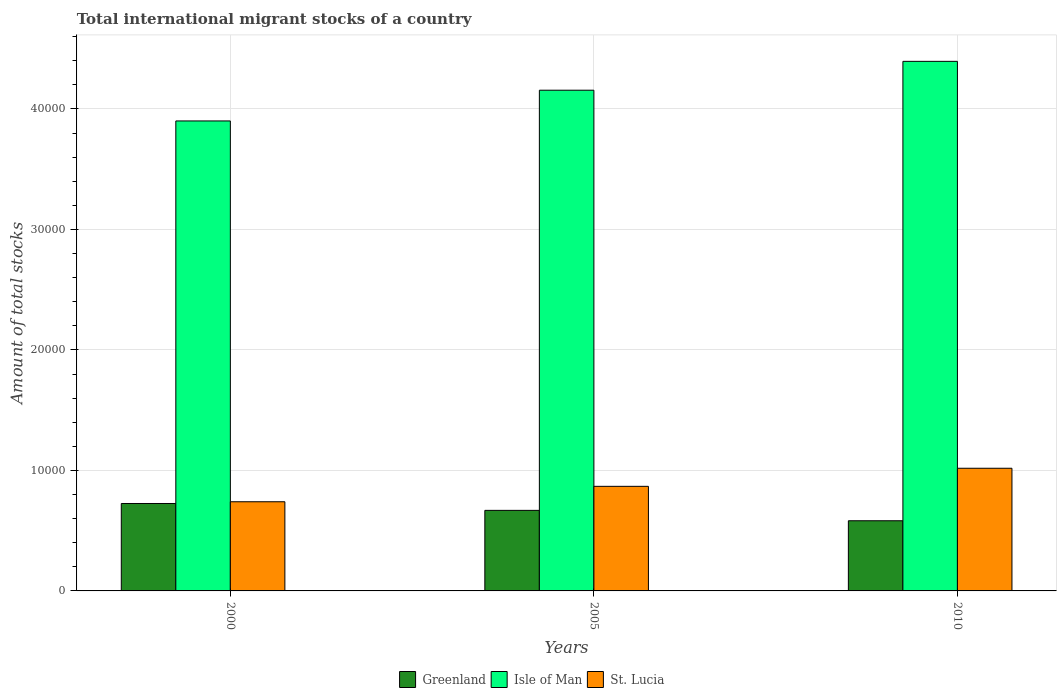Are the number of bars per tick equal to the number of legend labels?
Give a very brief answer. Yes. Are the number of bars on each tick of the X-axis equal?
Provide a succinct answer. Yes. What is the amount of total stocks in in Isle of Man in 2005?
Give a very brief answer. 4.16e+04. Across all years, what is the maximum amount of total stocks in in St. Lucia?
Give a very brief answer. 1.02e+04. Across all years, what is the minimum amount of total stocks in in Greenland?
Offer a very short reply. 5823. In which year was the amount of total stocks in in Isle of Man minimum?
Offer a terse response. 2000. What is the total amount of total stocks in in Isle of Man in the graph?
Offer a terse response. 1.25e+05. What is the difference between the amount of total stocks in in Isle of Man in 2000 and that in 2010?
Your response must be concise. -4945. What is the difference between the amount of total stocks in in St. Lucia in 2010 and the amount of total stocks in in Greenland in 2005?
Give a very brief answer. 3495. What is the average amount of total stocks in in St. Lucia per year?
Your response must be concise. 8753. In the year 2010, what is the difference between the amount of total stocks in in St. Lucia and amount of total stocks in in Isle of Man?
Ensure brevity in your answer.  -3.38e+04. In how many years, is the amount of total stocks in in St. Lucia greater than 2000?
Your response must be concise. 3. What is the ratio of the amount of total stocks in in St. Lucia in 2005 to that in 2010?
Give a very brief answer. 0.85. Is the amount of total stocks in in Greenland in 2000 less than that in 2005?
Make the answer very short. No. Is the difference between the amount of total stocks in in St. Lucia in 2000 and 2005 greater than the difference between the amount of total stocks in in Isle of Man in 2000 and 2005?
Provide a short and direct response. Yes. What is the difference between the highest and the second highest amount of total stocks in in St. Lucia?
Your answer should be very brief. 1501. What is the difference between the highest and the lowest amount of total stocks in in Greenland?
Make the answer very short. 1433. In how many years, is the amount of total stocks in in Greenland greater than the average amount of total stocks in in Greenland taken over all years?
Provide a succinct answer. 2. Is the sum of the amount of total stocks in in Isle of Man in 2000 and 2010 greater than the maximum amount of total stocks in in St. Lucia across all years?
Your answer should be compact. Yes. What does the 2nd bar from the left in 2010 represents?
Make the answer very short. Isle of Man. What does the 1st bar from the right in 2000 represents?
Keep it short and to the point. St. Lucia. Is it the case that in every year, the sum of the amount of total stocks in in Isle of Man and amount of total stocks in in Greenland is greater than the amount of total stocks in in St. Lucia?
Offer a very short reply. Yes. How many bars are there?
Keep it short and to the point. 9. Does the graph contain grids?
Give a very brief answer. Yes. How are the legend labels stacked?
Ensure brevity in your answer.  Horizontal. What is the title of the graph?
Your response must be concise. Total international migrant stocks of a country. What is the label or title of the Y-axis?
Give a very brief answer. Amount of total stocks. What is the Amount of total stocks in Greenland in 2000?
Provide a short and direct response. 7256. What is the Amount of total stocks of Isle of Man in 2000?
Offer a very short reply. 3.90e+04. What is the Amount of total stocks in St. Lucia in 2000?
Your response must be concise. 7400. What is the Amount of total stocks in Greenland in 2005?
Make the answer very short. 6685. What is the Amount of total stocks in Isle of Man in 2005?
Ensure brevity in your answer.  4.16e+04. What is the Amount of total stocks in St. Lucia in 2005?
Your answer should be very brief. 8679. What is the Amount of total stocks of Greenland in 2010?
Your answer should be very brief. 5823. What is the Amount of total stocks of Isle of Man in 2010?
Offer a very short reply. 4.39e+04. What is the Amount of total stocks in St. Lucia in 2010?
Offer a terse response. 1.02e+04. Across all years, what is the maximum Amount of total stocks of Greenland?
Ensure brevity in your answer.  7256. Across all years, what is the maximum Amount of total stocks in Isle of Man?
Give a very brief answer. 4.39e+04. Across all years, what is the maximum Amount of total stocks of St. Lucia?
Give a very brief answer. 1.02e+04. Across all years, what is the minimum Amount of total stocks of Greenland?
Offer a terse response. 5823. Across all years, what is the minimum Amount of total stocks in Isle of Man?
Offer a very short reply. 3.90e+04. Across all years, what is the minimum Amount of total stocks of St. Lucia?
Offer a very short reply. 7400. What is the total Amount of total stocks in Greenland in the graph?
Ensure brevity in your answer.  1.98e+04. What is the total Amount of total stocks of Isle of Man in the graph?
Offer a terse response. 1.25e+05. What is the total Amount of total stocks in St. Lucia in the graph?
Ensure brevity in your answer.  2.63e+04. What is the difference between the Amount of total stocks in Greenland in 2000 and that in 2005?
Give a very brief answer. 571. What is the difference between the Amount of total stocks in Isle of Man in 2000 and that in 2005?
Give a very brief answer. -2550. What is the difference between the Amount of total stocks in St. Lucia in 2000 and that in 2005?
Your response must be concise. -1279. What is the difference between the Amount of total stocks of Greenland in 2000 and that in 2010?
Your response must be concise. 1433. What is the difference between the Amount of total stocks in Isle of Man in 2000 and that in 2010?
Provide a succinct answer. -4945. What is the difference between the Amount of total stocks of St. Lucia in 2000 and that in 2010?
Your response must be concise. -2780. What is the difference between the Amount of total stocks of Greenland in 2005 and that in 2010?
Provide a succinct answer. 862. What is the difference between the Amount of total stocks in Isle of Man in 2005 and that in 2010?
Your answer should be very brief. -2395. What is the difference between the Amount of total stocks of St. Lucia in 2005 and that in 2010?
Your response must be concise. -1501. What is the difference between the Amount of total stocks in Greenland in 2000 and the Amount of total stocks in Isle of Man in 2005?
Your response must be concise. -3.43e+04. What is the difference between the Amount of total stocks in Greenland in 2000 and the Amount of total stocks in St. Lucia in 2005?
Give a very brief answer. -1423. What is the difference between the Amount of total stocks of Isle of Man in 2000 and the Amount of total stocks of St. Lucia in 2005?
Offer a terse response. 3.03e+04. What is the difference between the Amount of total stocks in Greenland in 2000 and the Amount of total stocks in Isle of Man in 2010?
Ensure brevity in your answer.  -3.67e+04. What is the difference between the Amount of total stocks in Greenland in 2000 and the Amount of total stocks in St. Lucia in 2010?
Offer a terse response. -2924. What is the difference between the Amount of total stocks in Isle of Man in 2000 and the Amount of total stocks in St. Lucia in 2010?
Provide a short and direct response. 2.88e+04. What is the difference between the Amount of total stocks of Greenland in 2005 and the Amount of total stocks of Isle of Man in 2010?
Your answer should be compact. -3.73e+04. What is the difference between the Amount of total stocks of Greenland in 2005 and the Amount of total stocks of St. Lucia in 2010?
Offer a very short reply. -3495. What is the difference between the Amount of total stocks in Isle of Man in 2005 and the Amount of total stocks in St. Lucia in 2010?
Your response must be concise. 3.14e+04. What is the average Amount of total stocks in Greenland per year?
Make the answer very short. 6588. What is the average Amount of total stocks in Isle of Man per year?
Give a very brief answer. 4.15e+04. What is the average Amount of total stocks in St. Lucia per year?
Your response must be concise. 8753. In the year 2000, what is the difference between the Amount of total stocks of Greenland and Amount of total stocks of Isle of Man?
Make the answer very short. -3.17e+04. In the year 2000, what is the difference between the Amount of total stocks in Greenland and Amount of total stocks in St. Lucia?
Offer a very short reply. -144. In the year 2000, what is the difference between the Amount of total stocks in Isle of Man and Amount of total stocks in St. Lucia?
Ensure brevity in your answer.  3.16e+04. In the year 2005, what is the difference between the Amount of total stocks in Greenland and Amount of total stocks in Isle of Man?
Offer a very short reply. -3.49e+04. In the year 2005, what is the difference between the Amount of total stocks in Greenland and Amount of total stocks in St. Lucia?
Ensure brevity in your answer.  -1994. In the year 2005, what is the difference between the Amount of total stocks in Isle of Man and Amount of total stocks in St. Lucia?
Your response must be concise. 3.29e+04. In the year 2010, what is the difference between the Amount of total stocks in Greenland and Amount of total stocks in Isle of Man?
Offer a terse response. -3.81e+04. In the year 2010, what is the difference between the Amount of total stocks of Greenland and Amount of total stocks of St. Lucia?
Keep it short and to the point. -4357. In the year 2010, what is the difference between the Amount of total stocks in Isle of Man and Amount of total stocks in St. Lucia?
Your answer should be very brief. 3.38e+04. What is the ratio of the Amount of total stocks of Greenland in 2000 to that in 2005?
Provide a succinct answer. 1.09. What is the ratio of the Amount of total stocks of Isle of Man in 2000 to that in 2005?
Provide a succinct answer. 0.94. What is the ratio of the Amount of total stocks in St. Lucia in 2000 to that in 2005?
Make the answer very short. 0.85. What is the ratio of the Amount of total stocks in Greenland in 2000 to that in 2010?
Offer a very short reply. 1.25. What is the ratio of the Amount of total stocks in Isle of Man in 2000 to that in 2010?
Your answer should be very brief. 0.89. What is the ratio of the Amount of total stocks in St. Lucia in 2000 to that in 2010?
Offer a very short reply. 0.73. What is the ratio of the Amount of total stocks in Greenland in 2005 to that in 2010?
Provide a short and direct response. 1.15. What is the ratio of the Amount of total stocks of Isle of Man in 2005 to that in 2010?
Keep it short and to the point. 0.95. What is the ratio of the Amount of total stocks in St. Lucia in 2005 to that in 2010?
Provide a succinct answer. 0.85. What is the difference between the highest and the second highest Amount of total stocks of Greenland?
Your response must be concise. 571. What is the difference between the highest and the second highest Amount of total stocks of Isle of Man?
Make the answer very short. 2395. What is the difference between the highest and the second highest Amount of total stocks of St. Lucia?
Your answer should be very brief. 1501. What is the difference between the highest and the lowest Amount of total stocks of Greenland?
Your answer should be very brief. 1433. What is the difference between the highest and the lowest Amount of total stocks of Isle of Man?
Offer a terse response. 4945. What is the difference between the highest and the lowest Amount of total stocks in St. Lucia?
Your response must be concise. 2780. 